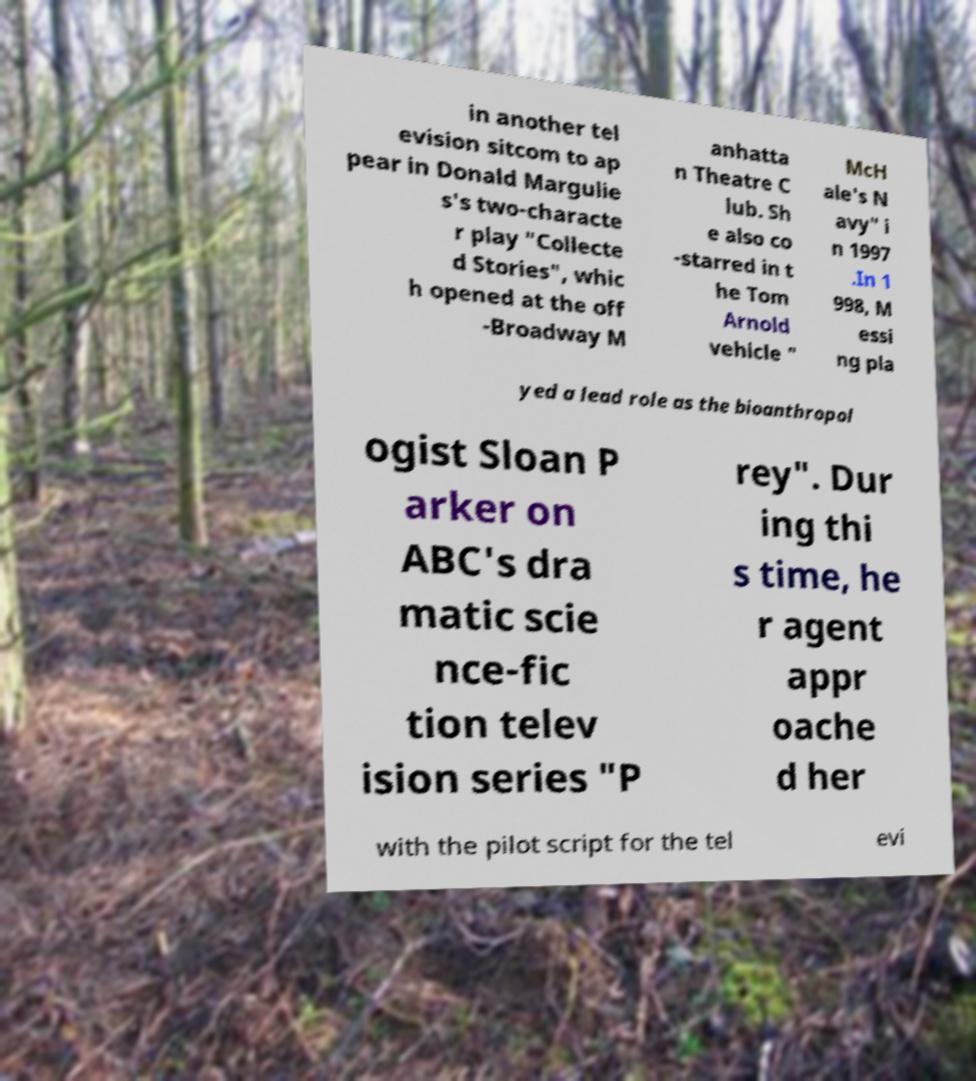Can you accurately transcribe the text from the provided image for me? in another tel evision sitcom to ap pear in Donald Margulie s's two-characte r play "Collecte d Stories", whic h opened at the off -Broadway M anhatta n Theatre C lub. Sh e also co -starred in t he Tom Arnold vehicle " McH ale's N avy" i n 1997 .In 1 998, M essi ng pla yed a lead role as the bioanthropol ogist Sloan P arker on ABC's dra matic scie nce-fic tion telev ision series "P rey". Dur ing thi s time, he r agent appr oache d her with the pilot script for the tel evi 